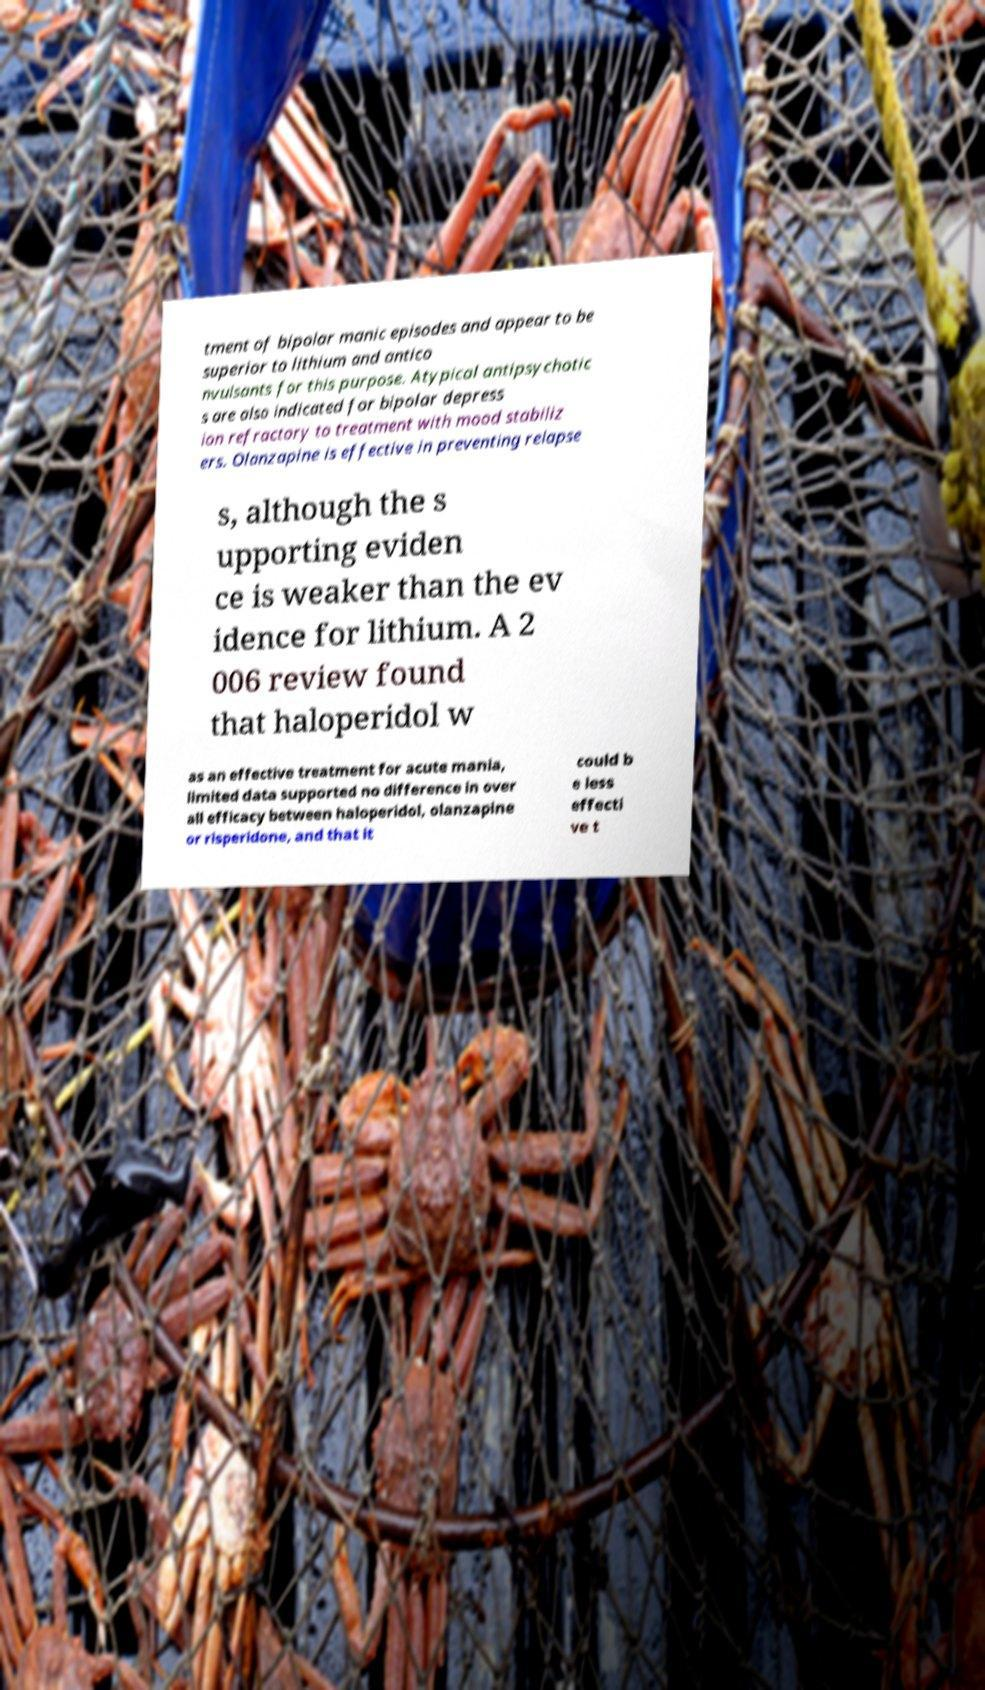Can you accurately transcribe the text from the provided image for me? tment of bipolar manic episodes and appear to be superior to lithium and antico nvulsants for this purpose. Atypical antipsychotic s are also indicated for bipolar depress ion refractory to treatment with mood stabiliz ers. Olanzapine is effective in preventing relapse s, although the s upporting eviden ce is weaker than the ev idence for lithium. A 2 006 review found that haloperidol w as an effective treatment for acute mania, limited data supported no difference in over all efficacy between haloperidol, olanzapine or risperidone, and that it could b e less effecti ve t 